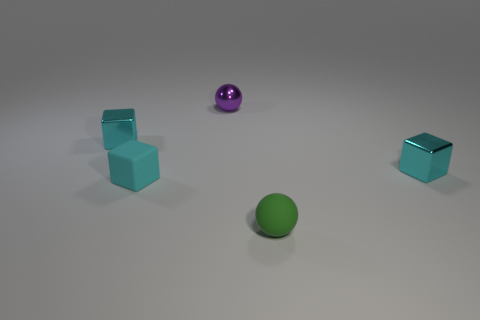What number of other objects are there of the same material as the green ball? Based on the image, there appears to be one other ball made of a similar shiny material, which is the purple ball. The two cubes, although colored, exhibit a matte finish and thus are likely made of a different material. 